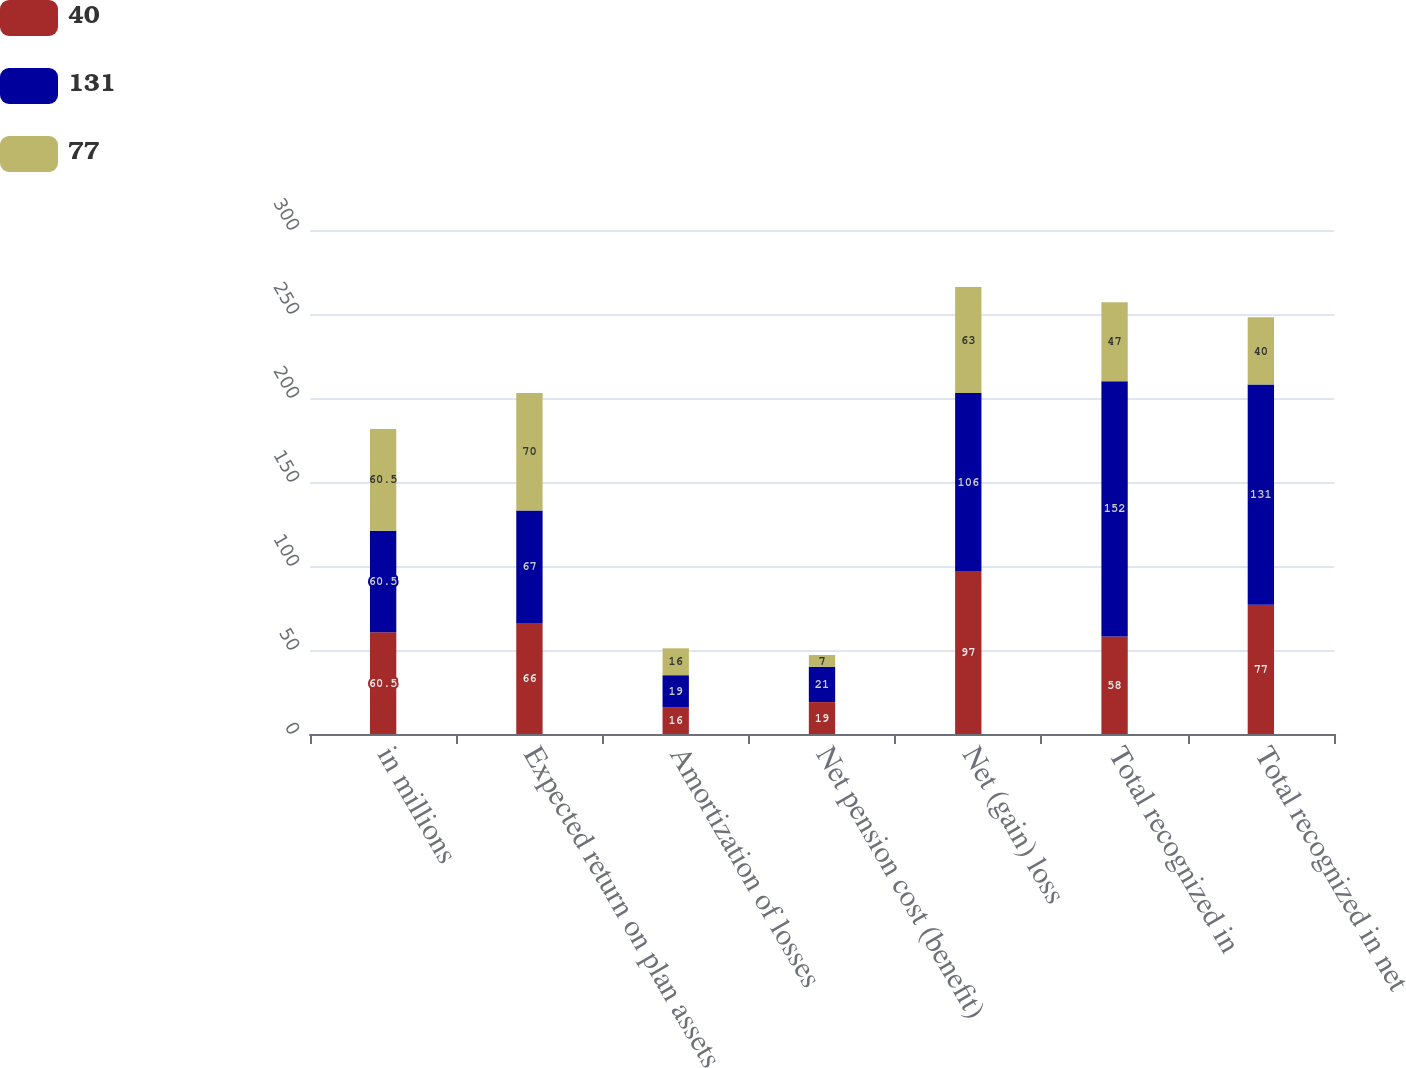<chart> <loc_0><loc_0><loc_500><loc_500><stacked_bar_chart><ecel><fcel>in millions<fcel>Expected return on plan assets<fcel>Amortization of losses<fcel>Net pension cost (benefit)<fcel>Net (gain) loss<fcel>Total recognized in<fcel>Total recognized in net<nl><fcel>40<fcel>60.5<fcel>66<fcel>16<fcel>19<fcel>97<fcel>58<fcel>77<nl><fcel>131<fcel>60.5<fcel>67<fcel>19<fcel>21<fcel>106<fcel>152<fcel>131<nl><fcel>77<fcel>60.5<fcel>70<fcel>16<fcel>7<fcel>63<fcel>47<fcel>40<nl></chart> 